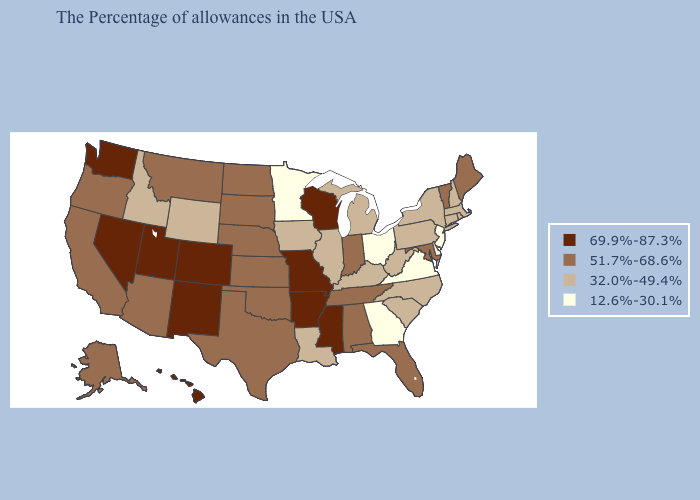What is the lowest value in the USA?
Give a very brief answer. 12.6%-30.1%. Among the states that border New York , does New Jersey have the lowest value?
Be succinct. Yes. Does Indiana have the lowest value in the MidWest?
Answer briefly. No. Does Tennessee have a lower value than Mississippi?
Give a very brief answer. Yes. Is the legend a continuous bar?
Answer briefly. No. Name the states that have a value in the range 12.6%-30.1%?
Short answer required. New Jersey, Delaware, Virginia, Ohio, Georgia, Minnesota. Which states have the highest value in the USA?
Short answer required. Wisconsin, Mississippi, Missouri, Arkansas, Colorado, New Mexico, Utah, Nevada, Washington, Hawaii. Does the first symbol in the legend represent the smallest category?
Write a very short answer. No. What is the lowest value in states that border Washington?
Short answer required. 32.0%-49.4%. Does Missouri have the highest value in the MidWest?
Be succinct. Yes. Does Arkansas have a lower value than Pennsylvania?
Concise answer only. No. What is the lowest value in the USA?
Quick response, please. 12.6%-30.1%. Does Delaware have the same value as Virginia?
Be succinct. Yes. What is the value of Michigan?
Write a very short answer. 32.0%-49.4%. Name the states that have a value in the range 32.0%-49.4%?
Answer briefly. Massachusetts, Rhode Island, New Hampshire, Connecticut, New York, Pennsylvania, North Carolina, South Carolina, West Virginia, Michigan, Kentucky, Illinois, Louisiana, Iowa, Wyoming, Idaho. 